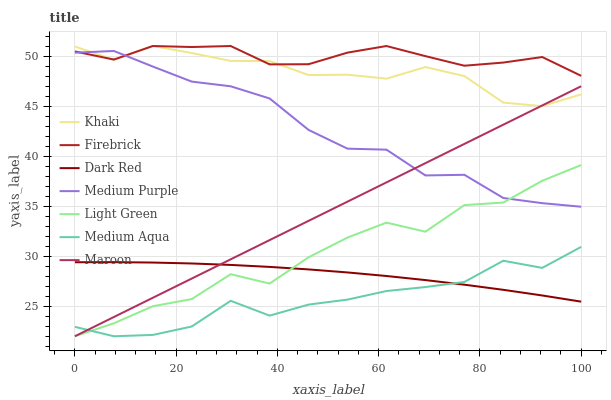Does Medium Aqua have the minimum area under the curve?
Answer yes or no. Yes. Does Firebrick have the maximum area under the curve?
Answer yes or no. Yes. Does Dark Red have the minimum area under the curve?
Answer yes or no. No. Does Dark Red have the maximum area under the curve?
Answer yes or no. No. Is Maroon the smoothest?
Answer yes or no. Yes. Is Light Green the roughest?
Answer yes or no. Yes. Is Dark Red the smoothest?
Answer yes or no. No. Is Dark Red the roughest?
Answer yes or no. No. Does Maroon have the lowest value?
Answer yes or no. Yes. Does Dark Red have the lowest value?
Answer yes or no. No. Does Firebrick have the highest value?
Answer yes or no. Yes. Does Dark Red have the highest value?
Answer yes or no. No. Is Dark Red less than Firebrick?
Answer yes or no. Yes. Is Medium Purple greater than Dark Red?
Answer yes or no. Yes. Does Khaki intersect Maroon?
Answer yes or no. Yes. Is Khaki less than Maroon?
Answer yes or no. No. Is Khaki greater than Maroon?
Answer yes or no. No. Does Dark Red intersect Firebrick?
Answer yes or no. No. 